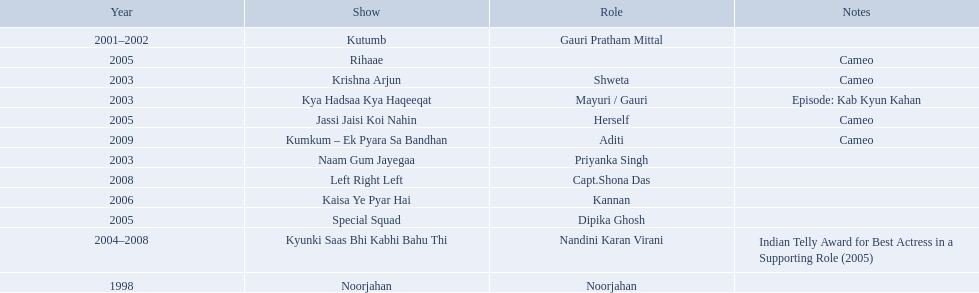What shows has gauri pradhan tejwani been in? Noorjahan, Kutumb, Krishna Arjun, Naam Gum Jayegaa, Kya Hadsaa Kya Haqeeqat, Kyunki Saas Bhi Kabhi Bahu Thi, Rihaae, Jassi Jaisi Koi Nahin, Special Squad, Kaisa Ye Pyar Hai, Left Right Left, Kumkum – Ek Pyara Sa Bandhan. Of these shows, which one lasted for more than a year? Kutumb, Kyunki Saas Bhi Kabhi Bahu Thi. Which of these lasted the longest? Kyunki Saas Bhi Kabhi Bahu Thi. 